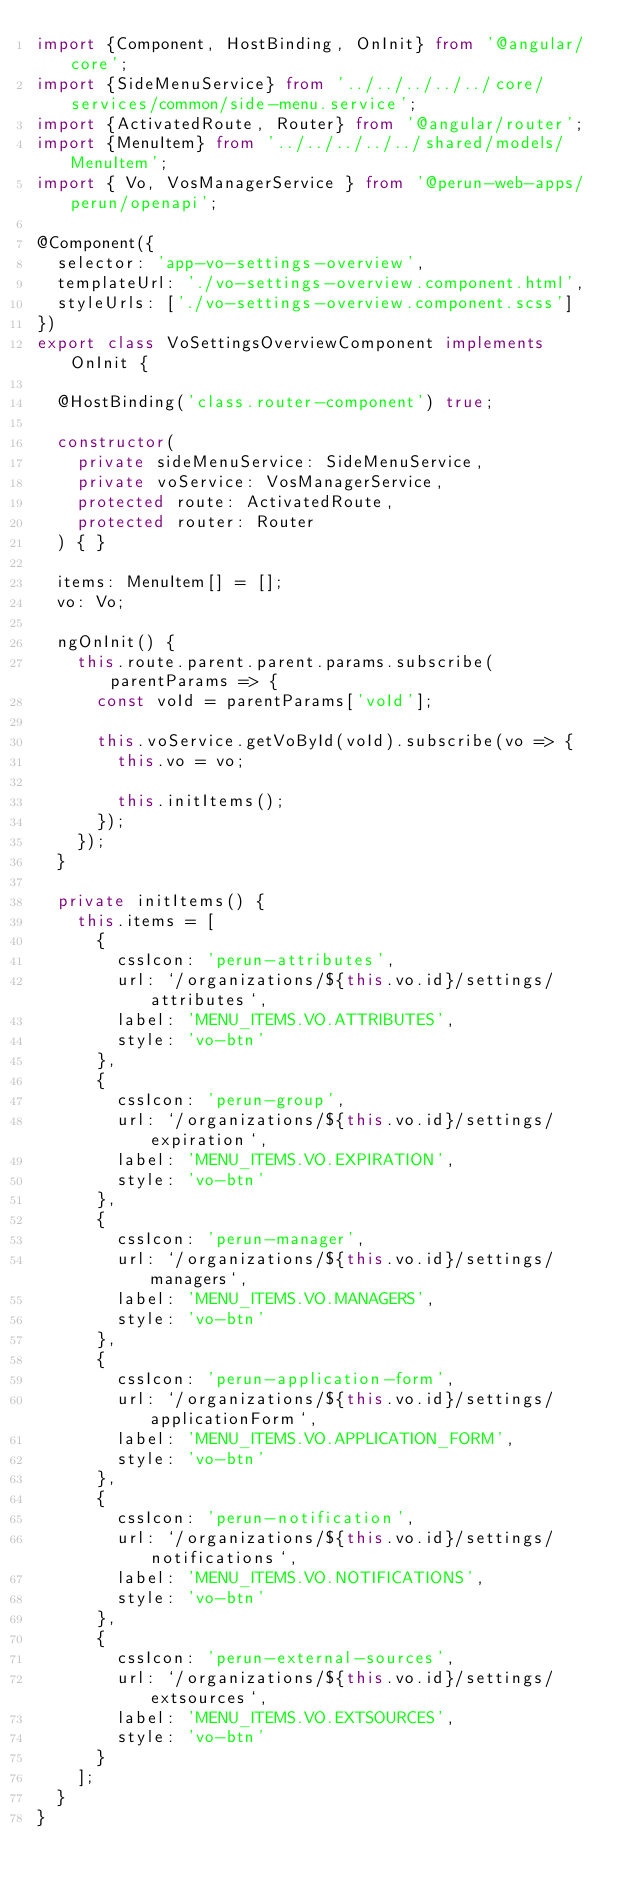Convert code to text. <code><loc_0><loc_0><loc_500><loc_500><_TypeScript_>import {Component, HostBinding, OnInit} from '@angular/core';
import {SideMenuService} from '../../../../../core/services/common/side-menu.service';
import {ActivatedRoute, Router} from '@angular/router';
import {MenuItem} from '../../../../../shared/models/MenuItem';
import { Vo, VosManagerService } from '@perun-web-apps/perun/openapi';

@Component({
  selector: 'app-vo-settings-overview',
  templateUrl: './vo-settings-overview.component.html',
  styleUrls: ['./vo-settings-overview.component.scss']
})
export class VoSettingsOverviewComponent implements OnInit {

  @HostBinding('class.router-component') true;

  constructor(
    private sideMenuService: SideMenuService,
    private voService: VosManagerService,
    protected route: ActivatedRoute,
    protected router: Router
  ) { }

  items: MenuItem[] = [];
  vo: Vo;

  ngOnInit() {
    this.route.parent.parent.params.subscribe(parentParams => {
      const voId = parentParams['voId'];

      this.voService.getVoById(voId).subscribe(vo => {
        this.vo = vo;

        this.initItems();
      });
    });
  }

  private initItems() {
    this.items = [
      {
        cssIcon: 'perun-attributes',
        url: `/organizations/${this.vo.id}/settings/attributes`,
        label: 'MENU_ITEMS.VO.ATTRIBUTES',
        style: 'vo-btn'
      },
      {
        cssIcon: 'perun-group',
        url: `/organizations/${this.vo.id}/settings/expiration`,
        label: 'MENU_ITEMS.VO.EXPIRATION',
        style: 'vo-btn'
      },
      {
        cssIcon: 'perun-manager',
        url: `/organizations/${this.vo.id}/settings/managers`,
        label: 'MENU_ITEMS.VO.MANAGERS',
        style: 'vo-btn'
      },
      {
        cssIcon: 'perun-application-form',
        url: `/organizations/${this.vo.id}/settings/applicationForm`,
        label: 'MENU_ITEMS.VO.APPLICATION_FORM',
        style: 'vo-btn'
      },
      {
        cssIcon: 'perun-notification',
        url: `/organizations/${this.vo.id}/settings/notifications`,
        label: 'MENU_ITEMS.VO.NOTIFICATIONS',
        style: 'vo-btn'
      },
      {
        cssIcon: 'perun-external-sources',
        url: `/organizations/${this.vo.id}/settings/extsources`,
        label: 'MENU_ITEMS.VO.EXTSOURCES',
        style: 'vo-btn'
      }
    ];
  }
}
</code> 